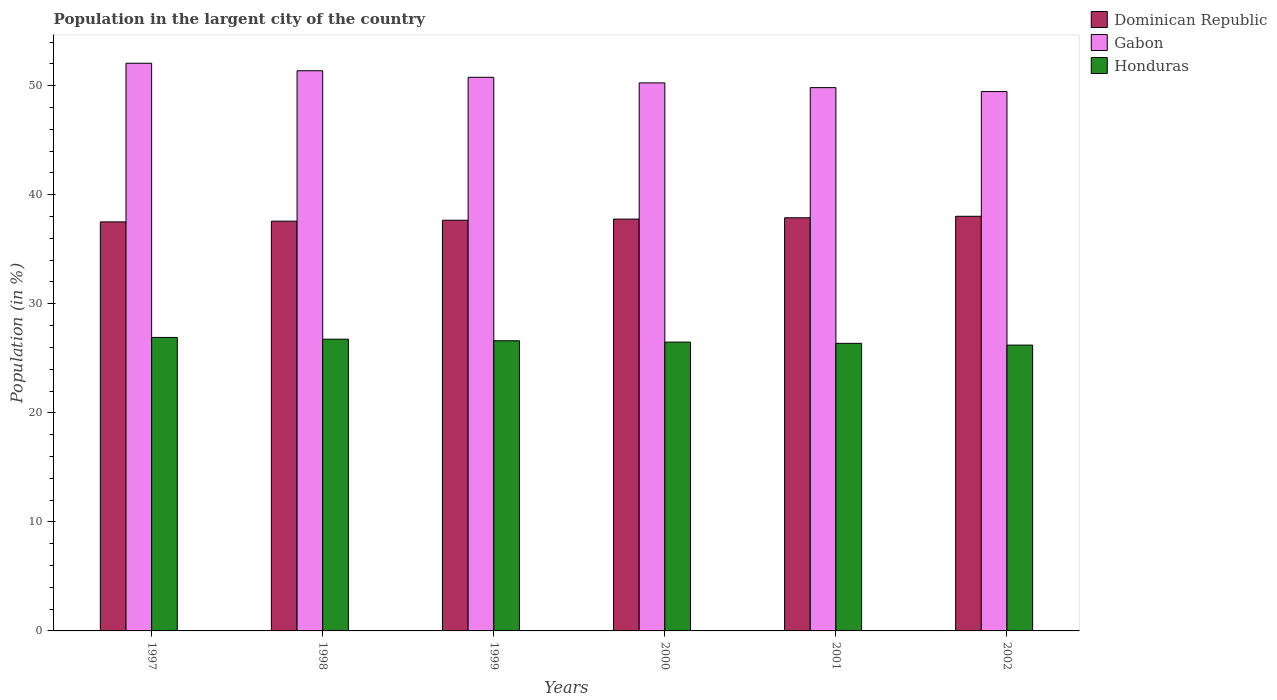How many groups of bars are there?
Your answer should be very brief. 6. How many bars are there on the 3rd tick from the left?
Offer a very short reply. 3. In how many cases, is the number of bars for a given year not equal to the number of legend labels?
Offer a terse response. 0. What is the percentage of population in the largent city in Honduras in 2001?
Offer a very short reply. 26.37. Across all years, what is the maximum percentage of population in the largent city in Dominican Republic?
Offer a terse response. 38.02. Across all years, what is the minimum percentage of population in the largent city in Honduras?
Provide a succinct answer. 26.21. What is the total percentage of population in the largent city in Honduras in the graph?
Your answer should be very brief. 159.35. What is the difference between the percentage of population in the largent city in Dominican Republic in 1997 and that in 2002?
Your answer should be very brief. -0.51. What is the difference between the percentage of population in the largent city in Honduras in 2000 and the percentage of population in the largent city in Gabon in 1997?
Provide a short and direct response. -25.57. What is the average percentage of population in the largent city in Gabon per year?
Keep it short and to the point. 50.62. In the year 1999, what is the difference between the percentage of population in the largent city in Dominican Republic and percentage of population in the largent city in Gabon?
Provide a succinct answer. -13.11. What is the ratio of the percentage of population in the largent city in Honduras in 2000 to that in 2002?
Your answer should be very brief. 1.01. Is the difference between the percentage of population in the largent city in Dominican Republic in 2000 and 2001 greater than the difference between the percentage of population in the largent city in Gabon in 2000 and 2001?
Your response must be concise. No. What is the difference between the highest and the second highest percentage of population in the largent city in Dominican Republic?
Make the answer very short. 0.14. What is the difference between the highest and the lowest percentage of population in the largent city in Gabon?
Ensure brevity in your answer.  2.6. What does the 3rd bar from the left in 2002 represents?
Keep it short and to the point. Honduras. What does the 3rd bar from the right in 2001 represents?
Offer a terse response. Dominican Republic. Is it the case that in every year, the sum of the percentage of population in the largent city in Gabon and percentage of population in the largent city in Honduras is greater than the percentage of population in the largent city in Dominican Republic?
Ensure brevity in your answer.  Yes. How many years are there in the graph?
Keep it short and to the point. 6. Does the graph contain any zero values?
Your answer should be very brief. No. Does the graph contain grids?
Your answer should be very brief. No. Where does the legend appear in the graph?
Your answer should be compact. Top right. What is the title of the graph?
Offer a terse response. Population in the largent city of the country. Does "Azerbaijan" appear as one of the legend labels in the graph?
Ensure brevity in your answer.  No. What is the label or title of the X-axis?
Your answer should be compact. Years. What is the label or title of the Y-axis?
Give a very brief answer. Population (in %). What is the Population (in %) in Dominican Republic in 1997?
Your response must be concise. 37.51. What is the Population (in %) in Gabon in 1997?
Give a very brief answer. 52.06. What is the Population (in %) in Honduras in 1997?
Ensure brevity in your answer.  26.92. What is the Population (in %) in Dominican Republic in 1998?
Your answer should be compact. 37.58. What is the Population (in %) in Gabon in 1998?
Make the answer very short. 51.37. What is the Population (in %) of Honduras in 1998?
Offer a very short reply. 26.75. What is the Population (in %) of Dominican Republic in 1999?
Offer a terse response. 37.66. What is the Population (in %) in Gabon in 1999?
Keep it short and to the point. 50.77. What is the Population (in %) in Honduras in 1999?
Give a very brief answer. 26.61. What is the Population (in %) of Dominican Republic in 2000?
Your answer should be very brief. 37.77. What is the Population (in %) in Gabon in 2000?
Offer a terse response. 50.26. What is the Population (in %) of Honduras in 2000?
Provide a short and direct response. 26.48. What is the Population (in %) in Dominican Republic in 2001?
Your answer should be very brief. 37.89. What is the Population (in %) of Gabon in 2001?
Give a very brief answer. 49.82. What is the Population (in %) in Honduras in 2001?
Provide a short and direct response. 26.37. What is the Population (in %) in Dominican Republic in 2002?
Your answer should be very brief. 38.02. What is the Population (in %) of Gabon in 2002?
Your answer should be compact. 49.46. What is the Population (in %) of Honduras in 2002?
Provide a short and direct response. 26.21. Across all years, what is the maximum Population (in %) of Dominican Republic?
Your answer should be compact. 38.02. Across all years, what is the maximum Population (in %) of Gabon?
Your answer should be very brief. 52.06. Across all years, what is the maximum Population (in %) in Honduras?
Provide a short and direct response. 26.92. Across all years, what is the minimum Population (in %) in Dominican Republic?
Your response must be concise. 37.51. Across all years, what is the minimum Population (in %) of Gabon?
Your answer should be compact. 49.46. Across all years, what is the minimum Population (in %) of Honduras?
Your answer should be compact. 26.21. What is the total Population (in %) of Dominican Republic in the graph?
Your answer should be compact. 226.43. What is the total Population (in %) of Gabon in the graph?
Provide a short and direct response. 303.75. What is the total Population (in %) of Honduras in the graph?
Your response must be concise. 159.35. What is the difference between the Population (in %) in Dominican Republic in 1997 and that in 1998?
Give a very brief answer. -0.07. What is the difference between the Population (in %) in Gabon in 1997 and that in 1998?
Ensure brevity in your answer.  0.69. What is the difference between the Population (in %) in Honduras in 1997 and that in 1998?
Offer a very short reply. 0.16. What is the difference between the Population (in %) in Dominican Republic in 1997 and that in 1999?
Ensure brevity in your answer.  -0.15. What is the difference between the Population (in %) of Gabon in 1997 and that in 1999?
Provide a short and direct response. 1.29. What is the difference between the Population (in %) of Honduras in 1997 and that in 1999?
Your response must be concise. 0.31. What is the difference between the Population (in %) in Dominican Republic in 1997 and that in 2000?
Your answer should be very brief. -0.26. What is the difference between the Population (in %) in Gabon in 1997 and that in 2000?
Give a very brief answer. 1.8. What is the difference between the Population (in %) of Honduras in 1997 and that in 2000?
Provide a short and direct response. 0.43. What is the difference between the Population (in %) of Dominican Republic in 1997 and that in 2001?
Offer a terse response. -0.38. What is the difference between the Population (in %) in Gabon in 1997 and that in 2001?
Ensure brevity in your answer.  2.23. What is the difference between the Population (in %) of Honduras in 1997 and that in 2001?
Offer a terse response. 0.54. What is the difference between the Population (in %) in Dominican Republic in 1997 and that in 2002?
Keep it short and to the point. -0.51. What is the difference between the Population (in %) in Gabon in 1997 and that in 2002?
Your answer should be compact. 2.6. What is the difference between the Population (in %) of Honduras in 1997 and that in 2002?
Your answer should be very brief. 0.7. What is the difference between the Population (in %) in Dominican Republic in 1998 and that in 1999?
Your answer should be very brief. -0.09. What is the difference between the Population (in %) of Gabon in 1998 and that in 1999?
Offer a very short reply. 0.6. What is the difference between the Population (in %) of Honduras in 1998 and that in 1999?
Give a very brief answer. 0.14. What is the difference between the Population (in %) of Dominican Republic in 1998 and that in 2000?
Your answer should be very brief. -0.19. What is the difference between the Population (in %) of Gabon in 1998 and that in 2000?
Provide a short and direct response. 1.11. What is the difference between the Population (in %) of Honduras in 1998 and that in 2000?
Give a very brief answer. 0.27. What is the difference between the Population (in %) in Dominican Republic in 1998 and that in 2001?
Offer a very short reply. -0.31. What is the difference between the Population (in %) of Gabon in 1998 and that in 2001?
Offer a terse response. 1.55. What is the difference between the Population (in %) in Honduras in 1998 and that in 2001?
Offer a very short reply. 0.38. What is the difference between the Population (in %) in Dominican Republic in 1998 and that in 2002?
Give a very brief answer. -0.45. What is the difference between the Population (in %) in Gabon in 1998 and that in 2002?
Your answer should be compact. 1.91. What is the difference between the Population (in %) of Honduras in 1998 and that in 2002?
Provide a short and direct response. 0.54. What is the difference between the Population (in %) in Dominican Republic in 1999 and that in 2000?
Ensure brevity in your answer.  -0.1. What is the difference between the Population (in %) of Gabon in 1999 and that in 2000?
Your response must be concise. 0.51. What is the difference between the Population (in %) of Honduras in 1999 and that in 2000?
Make the answer very short. 0.13. What is the difference between the Population (in %) of Dominican Republic in 1999 and that in 2001?
Provide a short and direct response. -0.22. What is the difference between the Population (in %) in Gabon in 1999 and that in 2001?
Offer a very short reply. 0.95. What is the difference between the Population (in %) of Honduras in 1999 and that in 2001?
Ensure brevity in your answer.  0.24. What is the difference between the Population (in %) in Dominican Republic in 1999 and that in 2002?
Offer a very short reply. -0.36. What is the difference between the Population (in %) of Gabon in 1999 and that in 2002?
Provide a succinct answer. 1.31. What is the difference between the Population (in %) of Honduras in 1999 and that in 2002?
Provide a short and direct response. 0.4. What is the difference between the Population (in %) in Dominican Republic in 2000 and that in 2001?
Keep it short and to the point. -0.12. What is the difference between the Population (in %) of Gabon in 2000 and that in 2001?
Make the answer very short. 0.43. What is the difference between the Population (in %) of Honduras in 2000 and that in 2001?
Provide a succinct answer. 0.11. What is the difference between the Population (in %) in Dominican Republic in 2000 and that in 2002?
Keep it short and to the point. -0.26. What is the difference between the Population (in %) of Gabon in 2000 and that in 2002?
Keep it short and to the point. 0.8. What is the difference between the Population (in %) of Honduras in 2000 and that in 2002?
Give a very brief answer. 0.27. What is the difference between the Population (in %) in Dominican Republic in 2001 and that in 2002?
Ensure brevity in your answer.  -0.14. What is the difference between the Population (in %) of Gabon in 2001 and that in 2002?
Provide a short and direct response. 0.36. What is the difference between the Population (in %) in Honduras in 2001 and that in 2002?
Your answer should be very brief. 0.16. What is the difference between the Population (in %) in Dominican Republic in 1997 and the Population (in %) in Gabon in 1998?
Your answer should be compact. -13.86. What is the difference between the Population (in %) of Dominican Republic in 1997 and the Population (in %) of Honduras in 1998?
Ensure brevity in your answer.  10.76. What is the difference between the Population (in %) of Gabon in 1997 and the Population (in %) of Honduras in 1998?
Keep it short and to the point. 25.31. What is the difference between the Population (in %) of Dominican Republic in 1997 and the Population (in %) of Gabon in 1999?
Your answer should be compact. -13.26. What is the difference between the Population (in %) of Dominican Republic in 1997 and the Population (in %) of Honduras in 1999?
Your response must be concise. 10.9. What is the difference between the Population (in %) in Gabon in 1997 and the Population (in %) in Honduras in 1999?
Keep it short and to the point. 25.45. What is the difference between the Population (in %) of Dominican Republic in 1997 and the Population (in %) of Gabon in 2000?
Your answer should be compact. -12.75. What is the difference between the Population (in %) of Dominican Republic in 1997 and the Population (in %) of Honduras in 2000?
Keep it short and to the point. 11.03. What is the difference between the Population (in %) in Gabon in 1997 and the Population (in %) in Honduras in 2000?
Give a very brief answer. 25.57. What is the difference between the Population (in %) in Dominican Republic in 1997 and the Population (in %) in Gabon in 2001?
Keep it short and to the point. -12.31. What is the difference between the Population (in %) of Dominican Republic in 1997 and the Population (in %) of Honduras in 2001?
Keep it short and to the point. 11.14. What is the difference between the Population (in %) in Gabon in 1997 and the Population (in %) in Honduras in 2001?
Make the answer very short. 25.68. What is the difference between the Population (in %) in Dominican Republic in 1997 and the Population (in %) in Gabon in 2002?
Offer a terse response. -11.95. What is the difference between the Population (in %) in Dominican Republic in 1997 and the Population (in %) in Honduras in 2002?
Offer a terse response. 11.3. What is the difference between the Population (in %) of Gabon in 1997 and the Population (in %) of Honduras in 2002?
Provide a succinct answer. 25.85. What is the difference between the Population (in %) in Dominican Republic in 1998 and the Population (in %) in Gabon in 1999?
Offer a terse response. -13.19. What is the difference between the Population (in %) of Dominican Republic in 1998 and the Population (in %) of Honduras in 1999?
Provide a short and direct response. 10.97. What is the difference between the Population (in %) in Gabon in 1998 and the Population (in %) in Honduras in 1999?
Give a very brief answer. 24.76. What is the difference between the Population (in %) of Dominican Republic in 1998 and the Population (in %) of Gabon in 2000?
Make the answer very short. -12.68. What is the difference between the Population (in %) in Dominican Republic in 1998 and the Population (in %) in Honduras in 2000?
Your answer should be very brief. 11.09. What is the difference between the Population (in %) of Gabon in 1998 and the Population (in %) of Honduras in 2000?
Your response must be concise. 24.89. What is the difference between the Population (in %) in Dominican Republic in 1998 and the Population (in %) in Gabon in 2001?
Make the answer very short. -12.25. What is the difference between the Population (in %) of Dominican Republic in 1998 and the Population (in %) of Honduras in 2001?
Provide a succinct answer. 11.2. What is the difference between the Population (in %) of Gabon in 1998 and the Population (in %) of Honduras in 2001?
Offer a terse response. 25. What is the difference between the Population (in %) in Dominican Republic in 1998 and the Population (in %) in Gabon in 2002?
Make the answer very short. -11.89. What is the difference between the Population (in %) of Dominican Republic in 1998 and the Population (in %) of Honduras in 2002?
Provide a succinct answer. 11.37. What is the difference between the Population (in %) of Gabon in 1998 and the Population (in %) of Honduras in 2002?
Give a very brief answer. 25.16. What is the difference between the Population (in %) of Dominican Republic in 1999 and the Population (in %) of Gabon in 2000?
Ensure brevity in your answer.  -12.59. What is the difference between the Population (in %) of Dominican Republic in 1999 and the Population (in %) of Honduras in 2000?
Give a very brief answer. 11.18. What is the difference between the Population (in %) in Gabon in 1999 and the Population (in %) in Honduras in 2000?
Provide a short and direct response. 24.29. What is the difference between the Population (in %) in Dominican Republic in 1999 and the Population (in %) in Gabon in 2001?
Provide a succinct answer. -12.16. What is the difference between the Population (in %) of Dominican Republic in 1999 and the Population (in %) of Honduras in 2001?
Make the answer very short. 11.29. What is the difference between the Population (in %) in Gabon in 1999 and the Population (in %) in Honduras in 2001?
Provide a short and direct response. 24.4. What is the difference between the Population (in %) in Dominican Republic in 1999 and the Population (in %) in Gabon in 2002?
Keep it short and to the point. -11.8. What is the difference between the Population (in %) in Dominican Republic in 1999 and the Population (in %) in Honduras in 2002?
Provide a short and direct response. 11.45. What is the difference between the Population (in %) in Gabon in 1999 and the Population (in %) in Honduras in 2002?
Provide a succinct answer. 24.56. What is the difference between the Population (in %) in Dominican Republic in 2000 and the Population (in %) in Gabon in 2001?
Keep it short and to the point. -12.06. What is the difference between the Population (in %) of Dominican Republic in 2000 and the Population (in %) of Honduras in 2001?
Ensure brevity in your answer.  11.39. What is the difference between the Population (in %) in Gabon in 2000 and the Population (in %) in Honduras in 2001?
Give a very brief answer. 23.88. What is the difference between the Population (in %) in Dominican Republic in 2000 and the Population (in %) in Gabon in 2002?
Your answer should be compact. -11.69. What is the difference between the Population (in %) of Dominican Republic in 2000 and the Population (in %) of Honduras in 2002?
Offer a very short reply. 11.56. What is the difference between the Population (in %) of Gabon in 2000 and the Population (in %) of Honduras in 2002?
Your response must be concise. 24.05. What is the difference between the Population (in %) in Dominican Republic in 2001 and the Population (in %) in Gabon in 2002?
Your answer should be compact. -11.57. What is the difference between the Population (in %) in Dominican Republic in 2001 and the Population (in %) in Honduras in 2002?
Offer a terse response. 11.68. What is the difference between the Population (in %) of Gabon in 2001 and the Population (in %) of Honduras in 2002?
Offer a terse response. 23.61. What is the average Population (in %) of Dominican Republic per year?
Offer a terse response. 37.74. What is the average Population (in %) in Gabon per year?
Provide a short and direct response. 50.62. What is the average Population (in %) of Honduras per year?
Make the answer very short. 26.56. In the year 1997, what is the difference between the Population (in %) in Dominican Republic and Population (in %) in Gabon?
Offer a terse response. -14.55. In the year 1997, what is the difference between the Population (in %) of Dominican Republic and Population (in %) of Honduras?
Offer a very short reply. 10.59. In the year 1997, what is the difference between the Population (in %) in Gabon and Population (in %) in Honduras?
Keep it short and to the point. 25.14. In the year 1998, what is the difference between the Population (in %) of Dominican Republic and Population (in %) of Gabon?
Offer a terse response. -13.8. In the year 1998, what is the difference between the Population (in %) of Dominican Republic and Population (in %) of Honduras?
Provide a short and direct response. 10.82. In the year 1998, what is the difference between the Population (in %) of Gabon and Population (in %) of Honduras?
Offer a terse response. 24.62. In the year 1999, what is the difference between the Population (in %) of Dominican Republic and Population (in %) of Gabon?
Keep it short and to the point. -13.11. In the year 1999, what is the difference between the Population (in %) in Dominican Republic and Population (in %) in Honduras?
Give a very brief answer. 11.05. In the year 1999, what is the difference between the Population (in %) of Gabon and Population (in %) of Honduras?
Give a very brief answer. 24.16. In the year 2000, what is the difference between the Population (in %) of Dominican Republic and Population (in %) of Gabon?
Make the answer very short. -12.49. In the year 2000, what is the difference between the Population (in %) in Dominican Republic and Population (in %) in Honduras?
Your answer should be compact. 11.28. In the year 2000, what is the difference between the Population (in %) in Gabon and Population (in %) in Honduras?
Keep it short and to the point. 23.77. In the year 2001, what is the difference between the Population (in %) in Dominican Republic and Population (in %) in Gabon?
Keep it short and to the point. -11.94. In the year 2001, what is the difference between the Population (in %) of Dominican Republic and Population (in %) of Honduras?
Your answer should be compact. 11.51. In the year 2001, what is the difference between the Population (in %) in Gabon and Population (in %) in Honduras?
Provide a short and direct response. 23.45. In the year 2002, what is the difference between the Population (in %) of Dominican Republic and Population (in %) of Gabon?
Provide a short and direct response. -11.44. In the year 2002, what is the difference between the Population (in %) in Dominican Republic and Population (in %) in Honduras?
Make the answer very short. 11.81. In the year 2002, what is the difference between the Population (in %) in Gabon and Population (in %) in Honduras?
Provide a short and direct response. 23.25. What is the ratio of the Population (in %) of Dominican Republic in 1997 to that in 1998?
Your response must be concise. 1. What is the ratio of the Population (in %) of Gabon in 1997 to that in 1998?
Your answer should be compact. 1.01. What is the ratio of the Population (in %) of Gabon in 1997 to that in 1999?
Your response must be concise. 1.03. What is the ratio of the Population (in %) in Honduras in 1997 to that in 1999?
Your response must be concise. 1.01. What is the ratio of the Population (in %) in Dominican Republic in 1997 to that in 2000?
Offer a very short reply. 0.99. What is the ratio of the Population (in %) of Gabon in 1997 to that in 2000?
Offer a very short reply. 1.04. What is the ratio of the Population (in %) of Honduras in 1997 to that in 2000?
Provide a short and direct response. 1.02. What is the ratio of the Population (in %) in Dominican Republic in 1997 to that in 2001?
Offer a terse response. 0.99. What is the ratio of the Population (in %) in Gabon in 1997 to that in 2001?
Give a very brief answer. 1.04. What is the ratio of the Population (in %) in Honduras in 1997 to that in 2001?
Your response must be concise. 1.02. What is the ratio of the Population (in %) in Dominican Republic in 1997 to that in 2002?
Give a very brief answer. 0.99. What is the ratio of the Population (in %) of Gabon in 1997 to that in 2002?
Provide a short and direct response. 1.05. What is the ratio of the Population (in %) in Honduras in 1997 to that in 2002?
Offer a terse response. 1.03. What is the ratio of the Population (in %) in Gabon in 1998 to that in 1999?
Offer a very short reply. 1.01. What is the ratio of the Population (in %) of Honduras in 1998 to that in 1999?
Keep it short and to the point. 1.01. What is the ratio of the Population (in %) in Dominican Republic in 1998 to that in 2000?
Provide a succinct answer. 0.99. What is the ratio of the Population (in %) in Gabon in 1998 to that in 2000?
Make the answer very short. 1.02. What is the ratio of the Population (in %) of Gabon in 1998 to that in 2001?
Your answer should be very brief. 1.03. What is the ratio of the Population (in %) of Honduras in 1998 to that in 2001?
Your response must be concise. 1.01. What is the ratio of the Population (in %) in Gabon in 1998 to that in 2002?
Keep it short and to the point. 1.04. What is the ratio of the Population (in %) in Honduras in 1998 to that in 2002?
Make the answer very short. 1.02. What is the ratio of the Population (in %) in Gabon in 1999 to that in 2000?
Your answer should be compact. 1.01. What is the ratio of the Population (in %) of Honduras in 1999 to that in 2000?
Keep it short and to the point. 1. What is the ratio of the Population (in %) of Dominican Republic in 1999 to that in 2001?
Offer a terse response. 0.99. What is the ratio of the Population (in %) in Honduras in 1999 to that in 2001?
Provide a short and direct response. 1.01. What is the ratio of the Population (in %) in Dominican Republic in 1999 to that in 2002?
Your answer should be compact. 0.99. What is the ratio of the Population (in %) in Gabon in 1999 to that in 2002?
Give a very brief answer. 1.03. What is the ratio of the Population (in %) in Honduras in 1999 to that in 2002?
Provide a short and direct response. 1.02. What is the ratio of the Population (in %) of Gabon in 2000 to that in 2001?
Give a very brief answer. 1.01. What is the ratio of the Population (in %) in Gabon in 2000 to that in 2002?
Ensure brevity in your answer.  1.02. What is the ratio of the Population (in %) of Honduras in 2000 to that in 2002?
Provide a succinct answer. 1.01. What is the ratio of the Population (in %) of Dominican Republic in 2001 to that in 2002?
Make the answer very short. 1. What is the ratio of the Population (in %) in Gabon in 2001 to that in 2002?
Give a very brief answer. 1.01. What is the difference between the highest and the second highest Population (in %) in Dominican Republic?
Keep it short and to the point. 0.14. What is the difference between the highest and the second highest Population (in %) of Gabon?
Offer a terse response. 0.69. What is the difference between the highest and the second highest Population (in %) in Honduras?
Provide a succinct answer. 0.16. What is the difference between the highest and the lowest Population (in %) in Dominican Republic?
Give a very brief answer. 0.51. What is the difference between the highest and the lowest Population (in %) in Gabon?
Offer a very short reply. 2.6. What is the difference between the highest and the lowest Population (in %) of Honduras?
Keep it short and to the point. 0.7. 